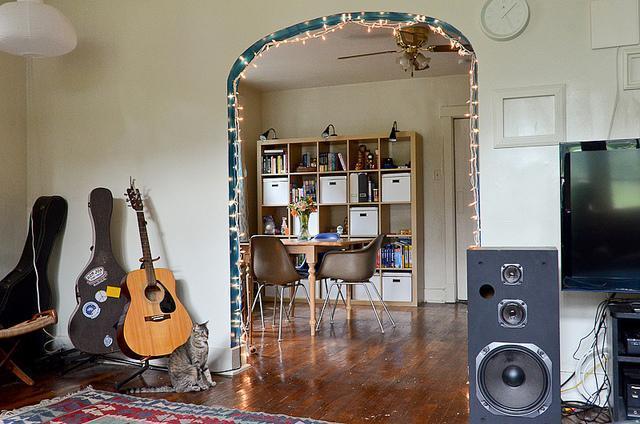How many guitar cases are there?
Give a very brief answer. 2. How many chairs are seen?
Give a very brief answer. 2. How many cats are in the photo?
Give a very brief answer. 1. How many chairs can be seen?
Give a very brief answer. 2. 